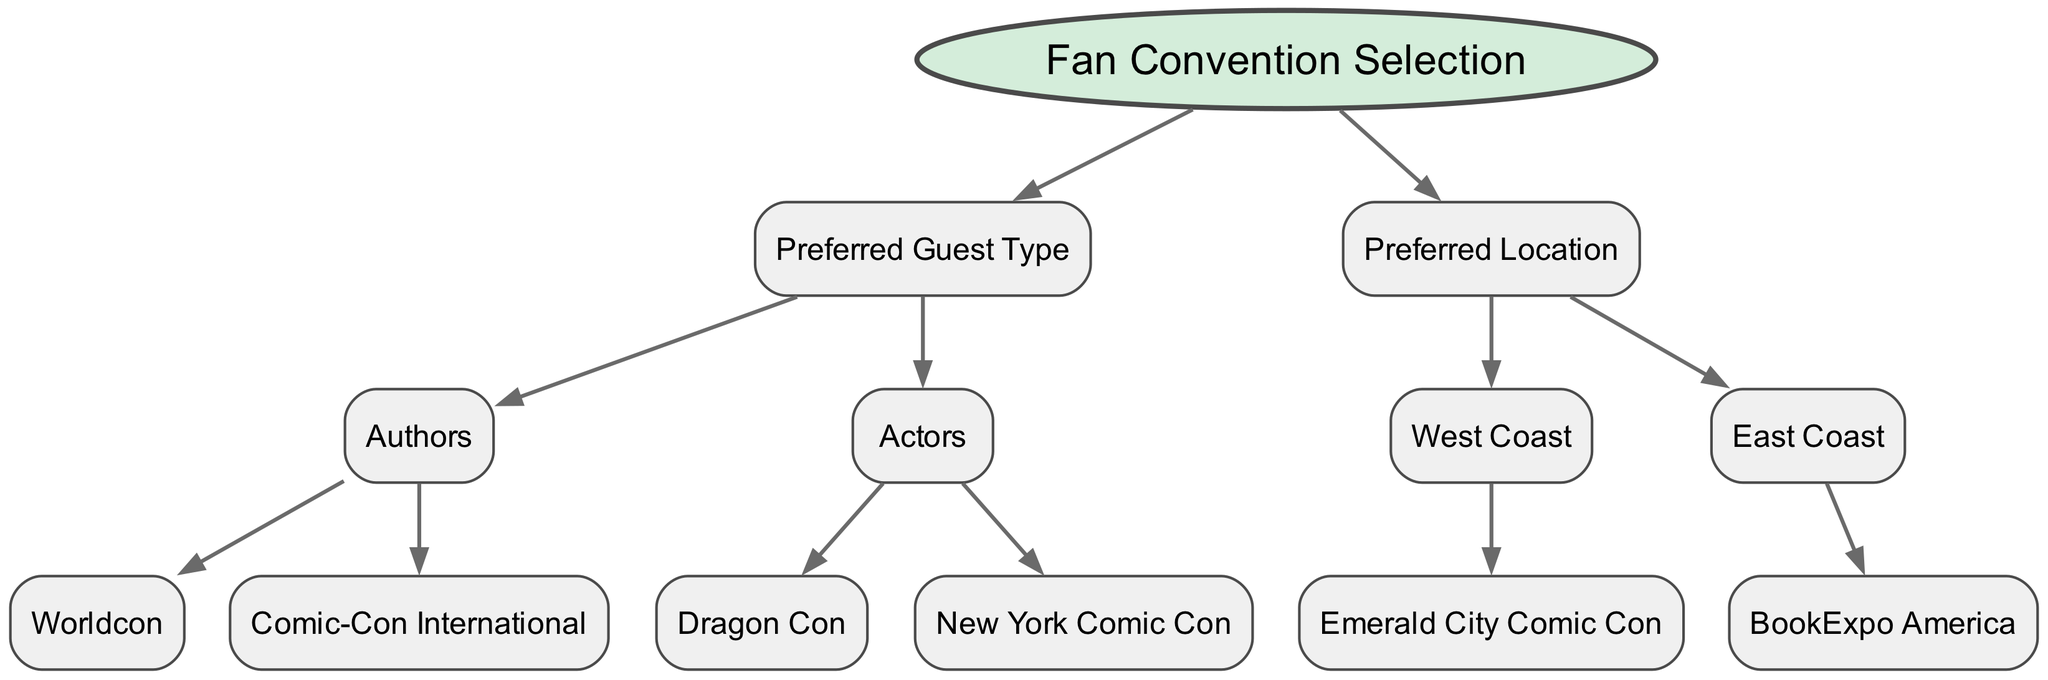What is the root node of this decision tree? The root node is labeled "Fan Convention Selection". It is the top-level node from which all decision branches stem, indicated by its distinct shape and position in the diagram.
Answer: Fan Convention Selection How many main categories are there in the decision tree? There are two main categories represented: "Preferred Guest Type" and "Preferred Location". Each of these categories contains further subdivisions.
Answer: 2 Which guest type leads to Worldcon? The guest type that leads to Worldcon is "Authors". This can be traced along the decision path starting from the root, through the first child node "Preferred Guest Type" to "Authors" and then to "Worldcon".
Answer: Authors What is the only convention listed under the West Coast location? The only convention listed under the West Coast location is "Emerald City Comic Con". It is the child node under "West Coast", which is a subdivision of "Preferred Location".
Answer: Emerald City Comic Con If someone prefers actors, which conventions could they attend? If someone prefers actors, they could attend either "Dragon Con" or "New York Comic Con". This flows from the "Preferred Guest Type" node to the child node "Actors", then branches into the two options.
Answer: Dragon Con, New York Comic Con How many total conventions are mentioned in this decision tree? There are six total conventions mentioned: Worldcon, Comic-Con International, Dragon Con, New York Comic Con, Emerald City Comic Con, and BookExpo America. This is a direct count of all terminal nodes in the tree.
Answer: 6 Which convention is associated with the East Coast location? The convention associated with the East Coast location is "BookExpo America". It is a child node under the "East Coast" node, which itself is under "Preferred Location".
Answer: BookExpo America What types of guests can be preferred according to this tree? The preferred types of guests according to the tree are "Authors" and "Actors". These are the two branches stemming from the "Preferred Guest Type" node.
Answer: Authors, Actors What is the relationship between "Emerald City Comic Con" and "West Coast"? "Emerald City Comic Con" is a child node of the "West Coast" node, indicating that it is a convention located on the West Coast according to the diagram.
Answer: Child node relationship 